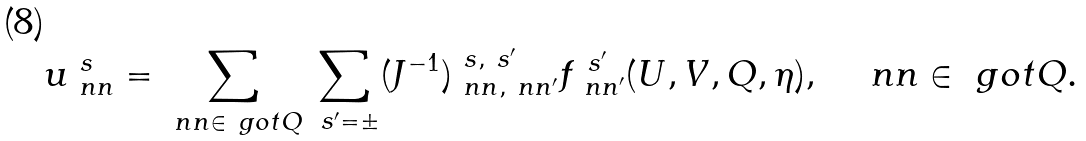<formula> <loc_0><loc_0><loc_500><loc_500>\, u ^ { \ s } _ { \ n n } = \sum _ { \ n n \in \ g o t Q } \sum _ { \ s ^ { \prime } = \pm } ( J ^ { - 1 } ) ^ { \ s , \ s ^ { \prime } } _ { \ n n , \ n n ^ { \prime } } f ^ { \ s ^ { \prime } } _ { \ n n ^ { \prime } } ( U , V , Q , \eta ) , \quad \ n n \in \ g o t Q .</formula> 